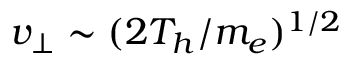<formula> <loc_0><loc_0><loc_500><loc_500>v _ { \perp } \sim ( 2 T _ { h } / m _ { e } ) ^ { 1 / 2 }</formula> 